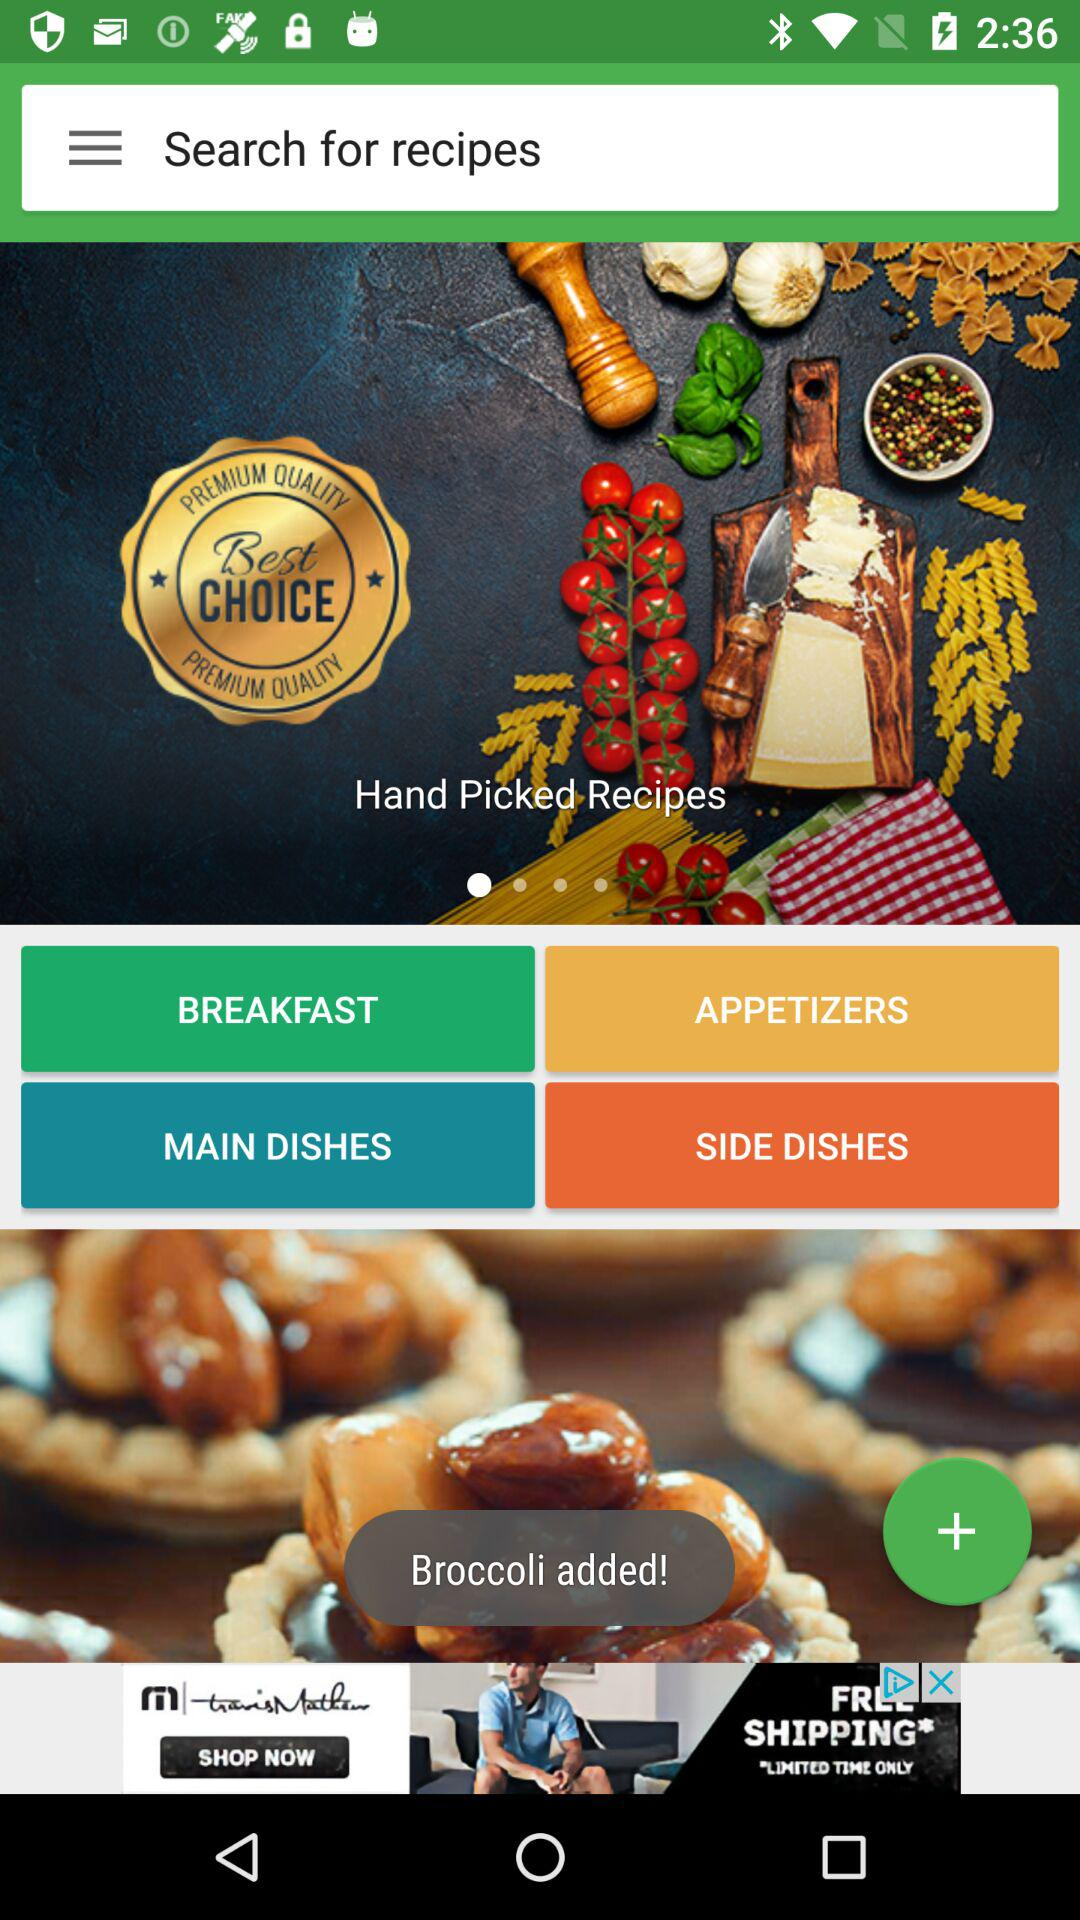Broccoli is added to which section of the recipes?
When the provided information is insufficient, respond with <no answer>. <no answer> 